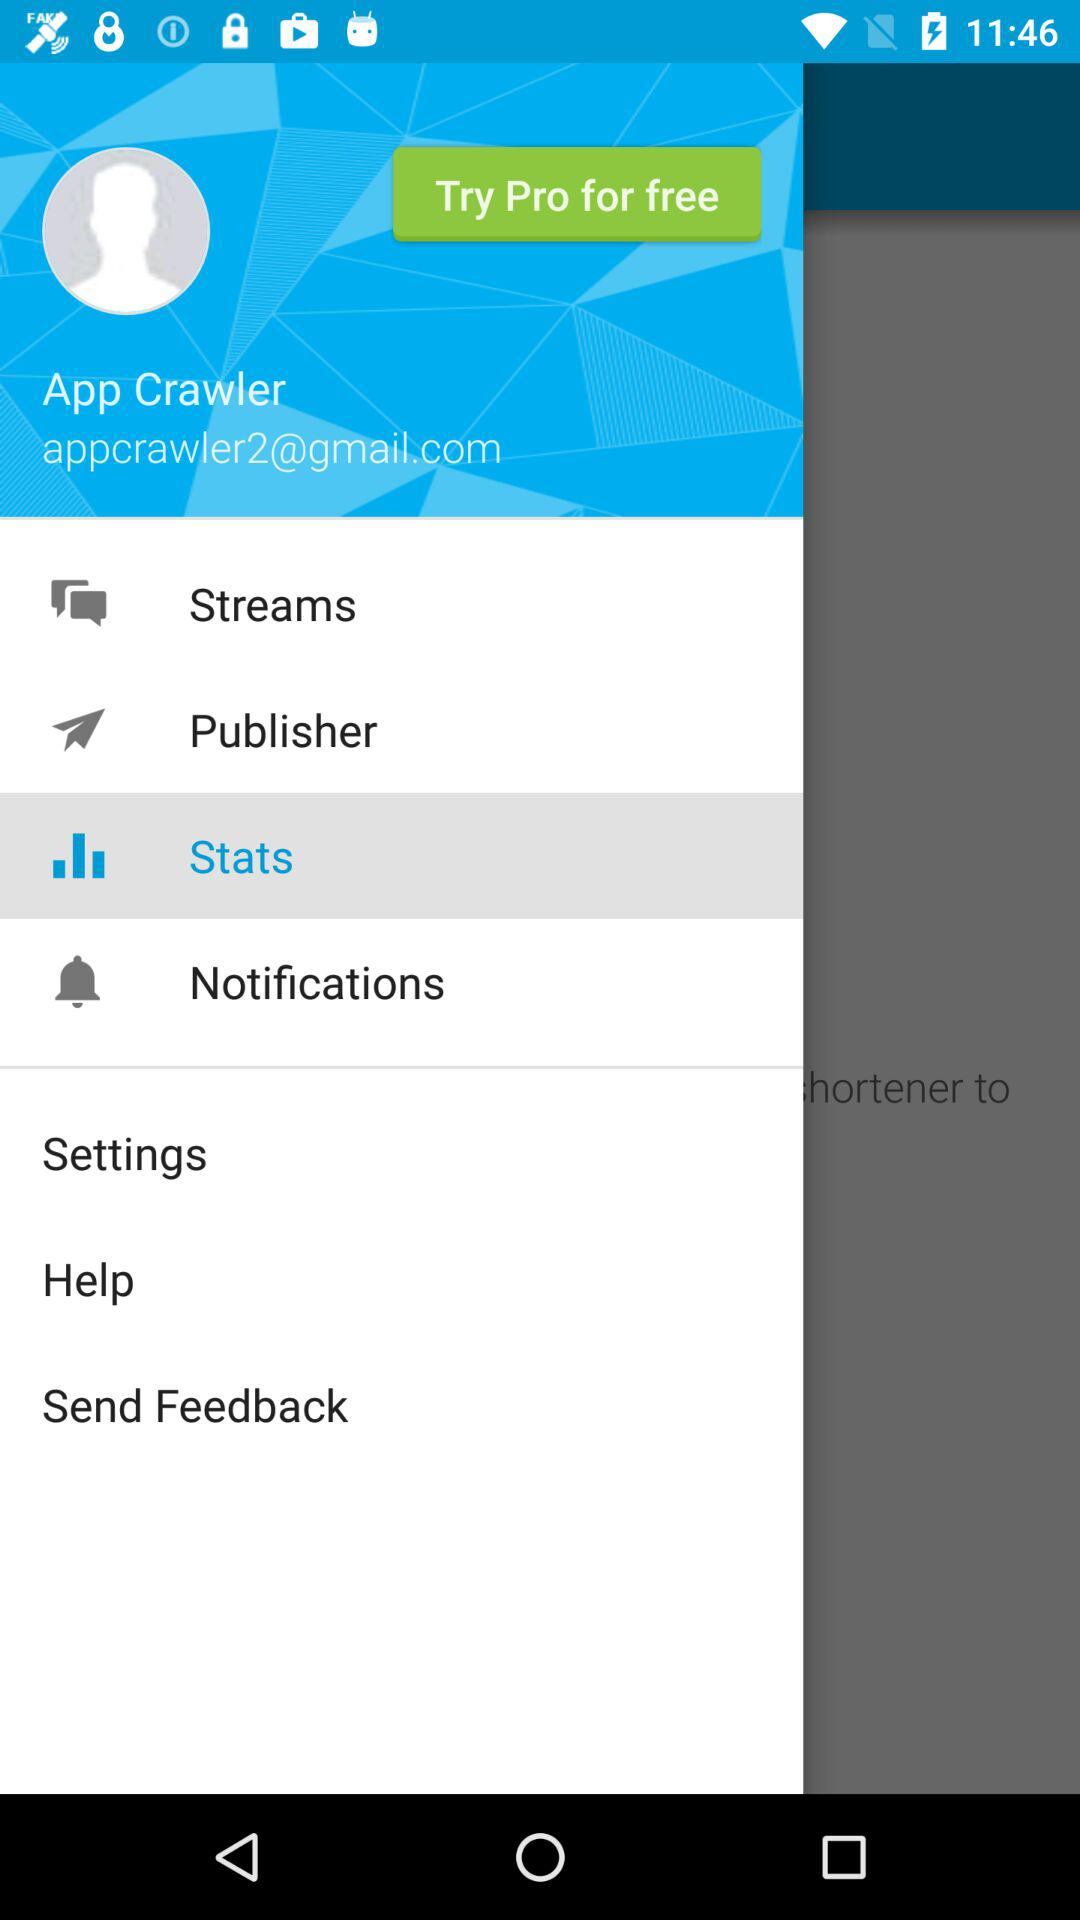What is the name of the user? The name of the user is App Crawler. 